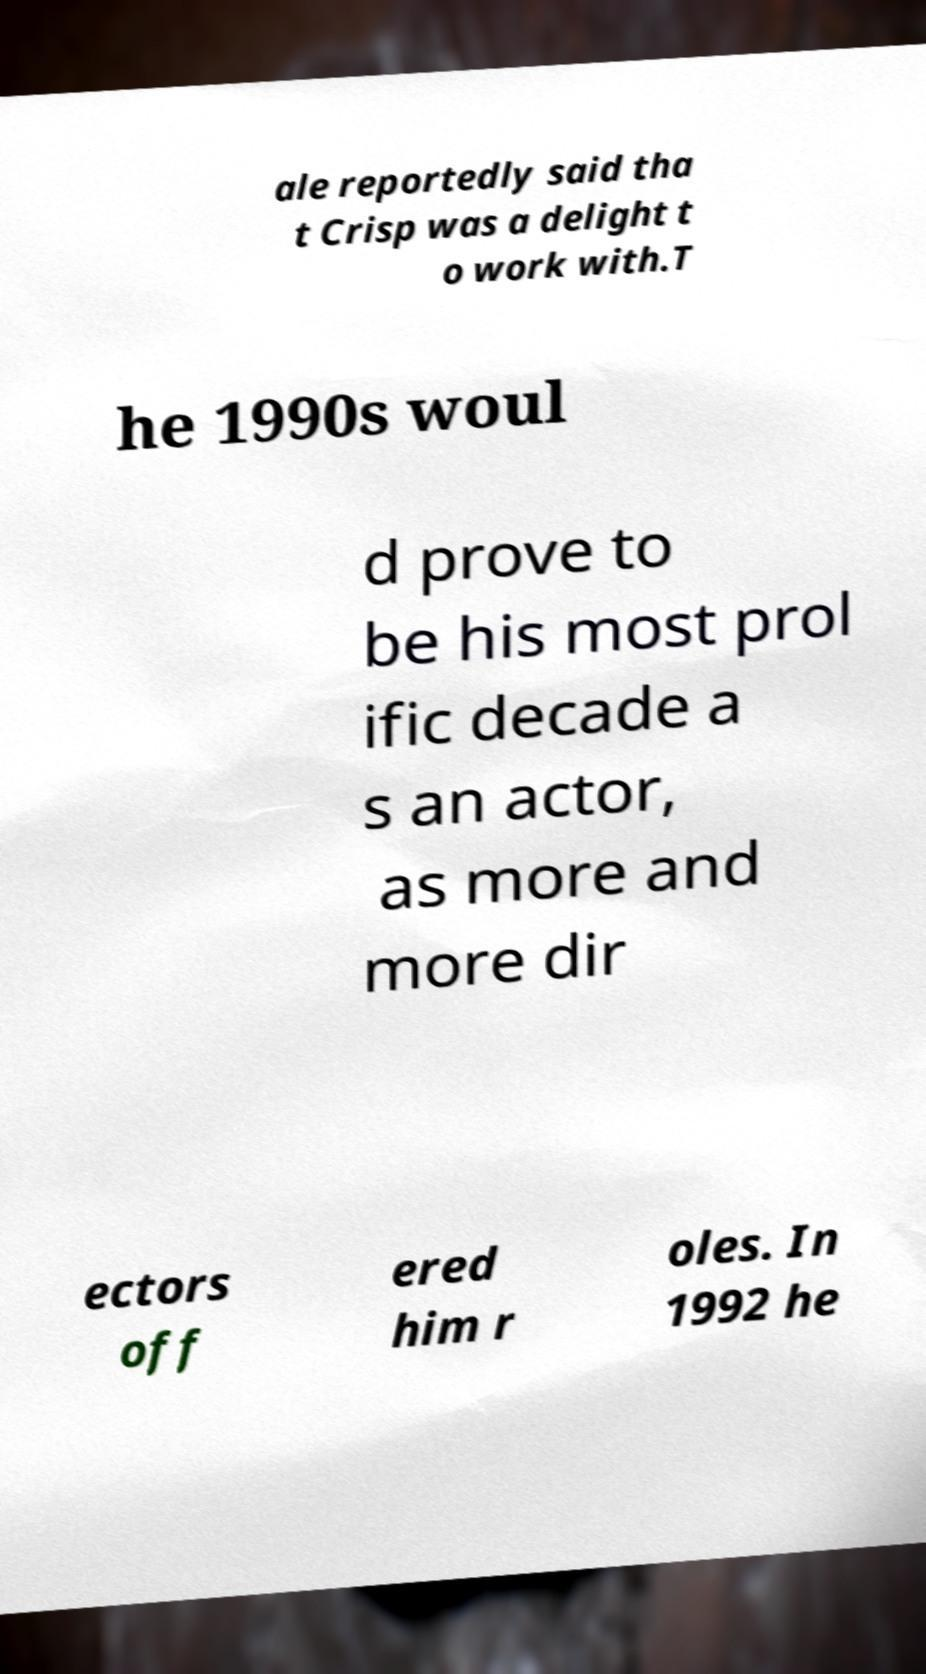Could you extract and type out the text from this image? ale reportedly said tha t Crisp was a delight t o work with.T he 1990s woul d prove to be his most prol ific decade a s an actor, as more and more dir ectors off ered him r oles. In 1992 he 